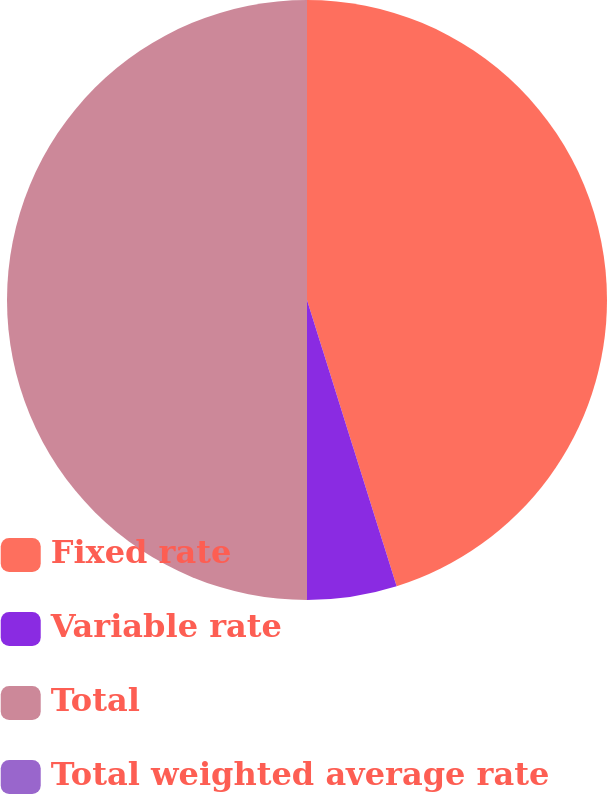Convert chart. <chart><loc_0><loc_0><loc_500><loc_500><pie_chart><fcel>Fixed rate<fcel>Variable rate<fcel>Total<fcel>Total weighted average rate<nl><fcel>45.17%<fcel>4.83%<fcel>50.0%<fcel>0.0%<nl></chart> 